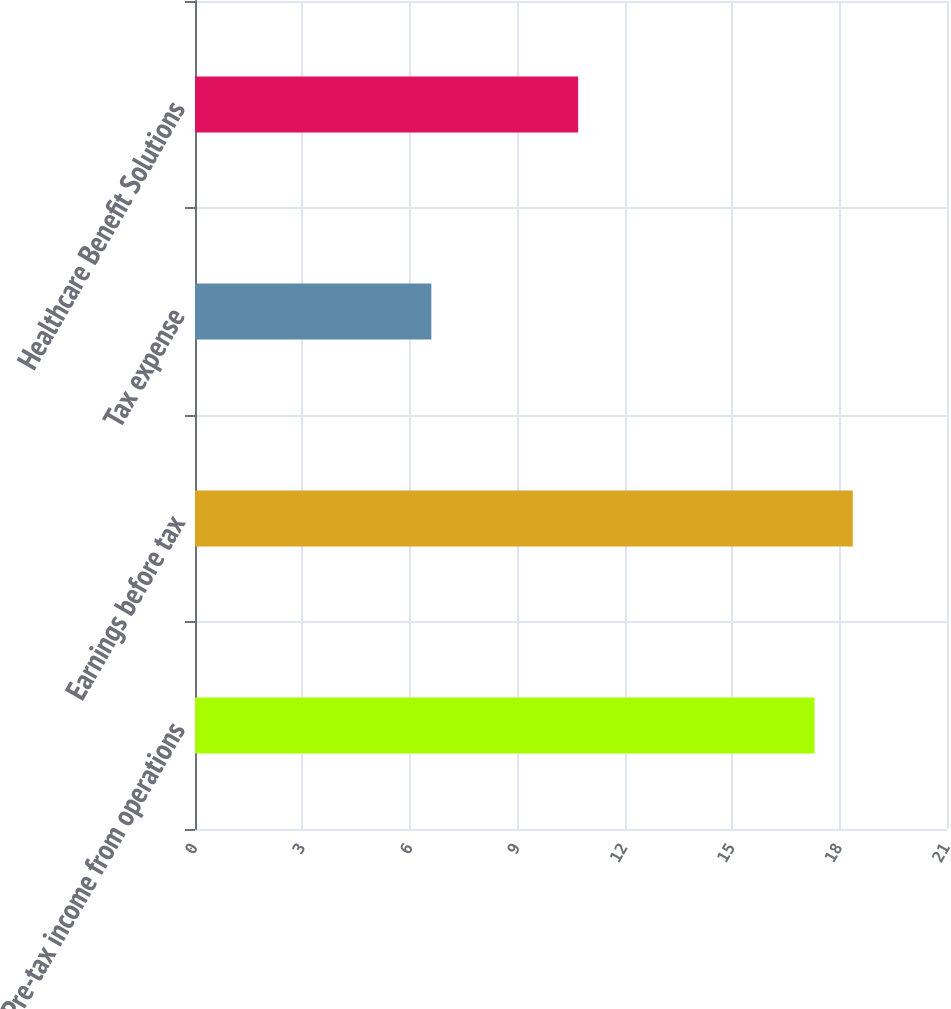Convert chart. <chart><loc_0><loc_0><loc_500><loc_500><bar_chart><fcel>Pre-tax income from operations<fcel>Earnings before tax<fcel>Tax expense<fcel>Healthcare Benefit Solutions<nl><fcel>17.3<fcel>18.37<fcel>6.6<fcel>10.7<nl></chart> 